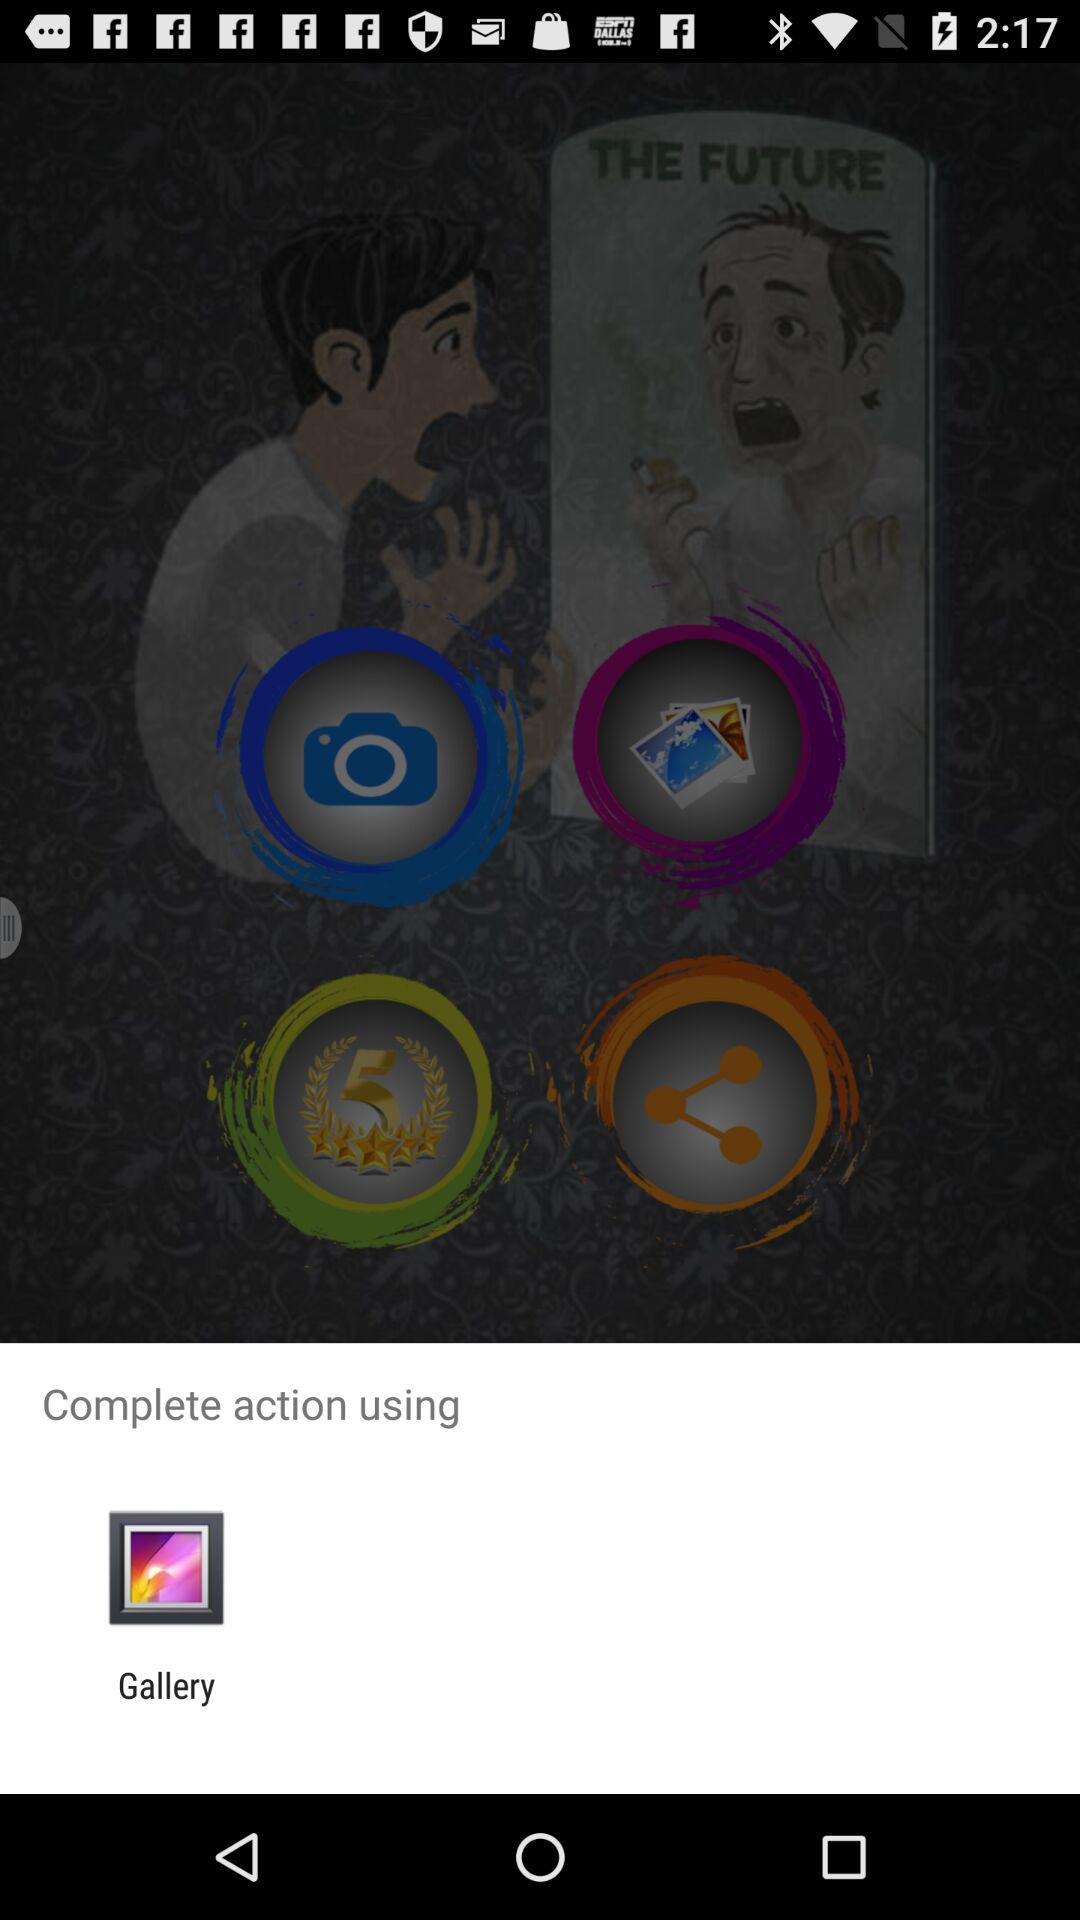What option is given for completing the action? The option given for completing the action is Gallery. 